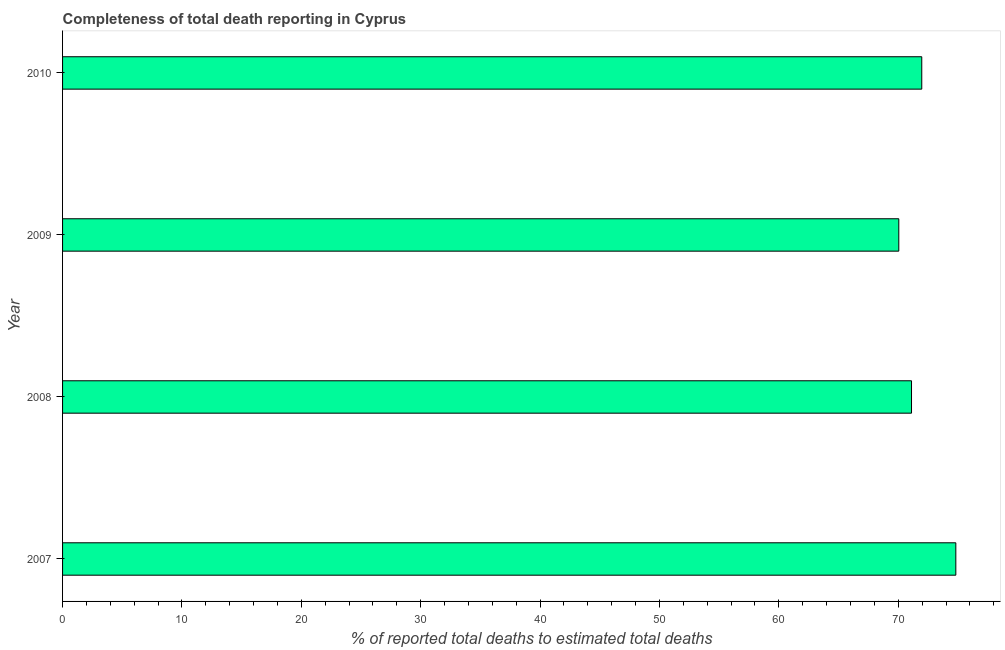What is the title of the graph?
Make the answer very short. Completeness of total death reporting in Cyprus. What is the label or title of the X-axis?
Your answer should be very brief. % of reported total deaths to estimated total deaths. What is the completeness of total death reports in 2008?
Ensure brevity in your answer.  71.11. Across all years, what is the maximum completeness of total death reports?
Your answer should be compact. 74.82. Across all years, what is the minimum completeness of total death reports?
Provide a short and direct response. 70.05. What is the sum of the completeness of total death reports?
Your answer should be compact. 287.95. What is the difference between the completeness of total death reports in 2007 and 2010?
Make the answer very short. 2.85. What is the average completeness of total death reports per year?
Provide a succinct answer. 71.99. What is the median completeness of total death reports?
Provide a succinct answer. 71.54. What is the ratio of the completeness of total death reports in 2007 to that in 2010?
Ensure brevity in your answer.  1.04. Is the completeness of total death reports in 2007 less than that in 2009?
Your response must be concise. No. What is the difference between the highest and the second highest completeness of total death reports?
Make the answer very short. 2.85. What is the difference between the highest and the lowest completeness of total death reports?
Give a very brief answer. 4.78. How many years are there in the graph?
Offer a terse response. 4. What is the % of reported total deaths to estimated total deaths in 2007?
Keep it short and to the point. 74.82. What is the % of reported total deaths to estimated total deaths of 2008?
Your answer should be compact. 71.11. What is the % of reported total deaths to estimated total deaths in 2009?
Provide a succinct answer. 70.05. What is the % of reported total deaths to estimated total deaths of 2010?
Your response must be concise. 71.97. What is the difference between the % of reported total deaths to estimated total deaths in 2007 and 2008?
Provide a succinct answer. 3.71. What is the difference between the % of reported total deaths to estimated total deaths in 2007 and 2009?
Make the answer very short. 4.78. What is the difference between the % of reported total deaths to estimated total deaths in 2007 and 2010?
Offer a very short reply. 2.85. What is the difference between the % of reported total deaths to estimated total deaths in 2008 and 2009?
Offer a terse response. 1.07. What is the difference between the % of reported total deaths to estimated total deaths in 2008 and 2010?
Your answer should be compact. -0.86. What is the difference between the % of reported total deaths to estimated total deaths in 2009 and 2010?
Ensure brevity in your answer.  -1.92. What is the ratio of the % of reported total deaths to estimated total deaths in 2007 to that in 2008?
Offer a terse response. 1.05. What is the ratio of the % of reported total deaths to estimated total deaths in 2007 to that in 2009?
Ensure brevity in your answer.  1.07. What is the ratio of the % of reported total deaths to estimated total deaths in 2008 to that in 2009?
Keep it short and to the point. 1.01. What is the ratio of the % of reported total deaths to estimated total deaths in 2008 to that in 2010?
Your answer should be very brief. 0.99. 